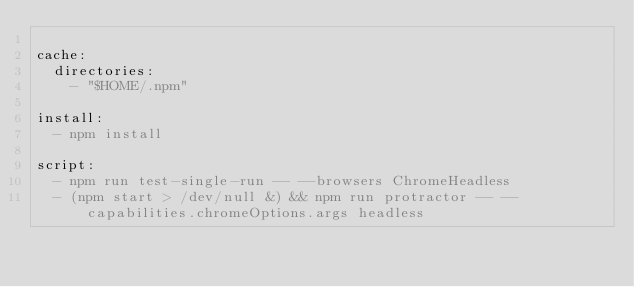Convert code to text. <code><loc_0><loc_0><loc_500><loc_500><_YAML_>
cache:
  directories:
    - "$HOME/.npm"

install:
  - npm install

script:
  - npm run test-single-run -- --browsers ChromeHeadless
  - (npm start > /dev/null &) && npm run protractor -- --capabilities.chromeOptions.args headless
</code> 